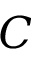<formula> <loc_0><loc_0><loc_500><loc_500>C</formula> 